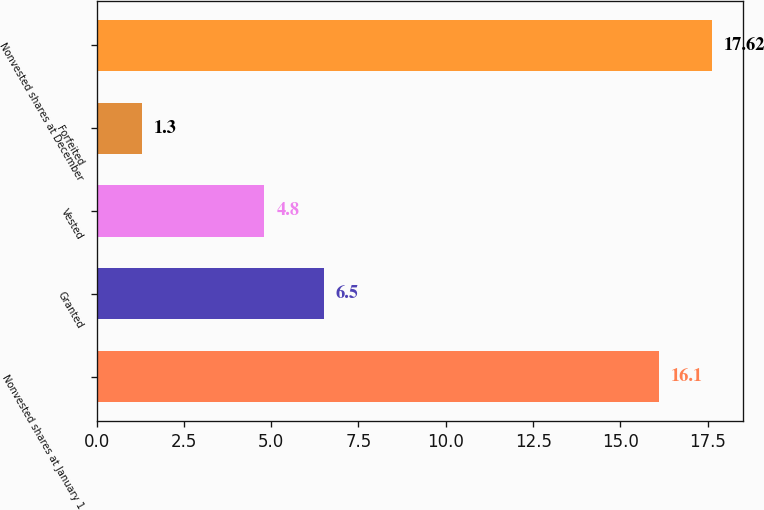Convert chart. <chart><loc_0><loc_0><loc_500><loc_500><bar_chart><fcel>Nonvested shares at January 1<fcel>Granted<fcel>Vested<fcel>Forfeited<fcel>Nonvested shares at December<nl><fcel>16.1<fcel>6.5<fcel>4.8<fcel>1.3<fcel>17.62<nl></chart> 